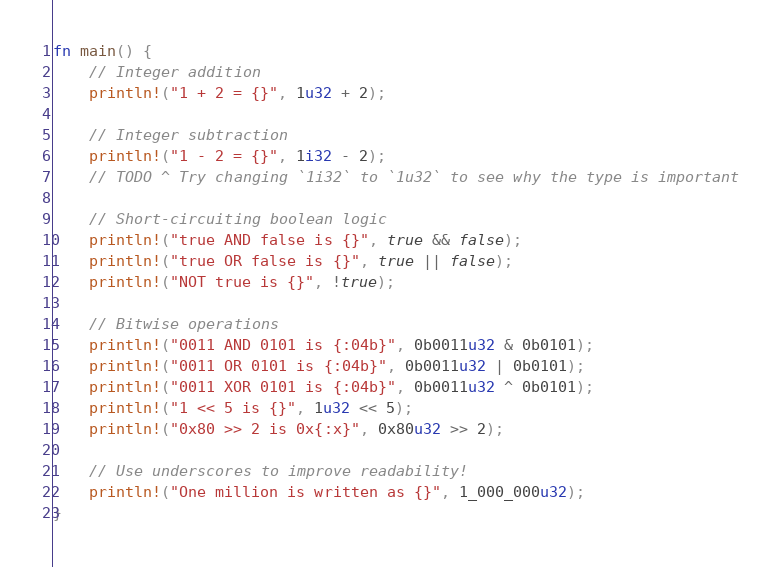Convert code to text. <code><loc_0><loc_0><loc_500><loc_500><_Rust_>fn main() {
    // Integer addition
    println!("1 + 2 = {}", 1u32 + 2);

    // Integer subtraction
    println!("1 - 2 = {}", 1i32 - 2);
    // TODO ^ Try changing `1i32` to `1u32` to see why the type is important

    // Short-circuiting boolean logic
    println!("true AND false is {}", true && false);
    println!("true OR false is {}", true || false);
    println!("NOT true is {}", !true);

    // Bitwise operations
    println!("0011 AND 0101 is {:04b}", 0b0011u32 & 0b0101);
    println!("0011 OR 0101 is {:04b}", 0b0011u32 | 0b0101);
    println!("0011 XOR 0101 is {:04b}", 0b0011u32 ^ 0b0101);
    println!("1 << 5 is {}", 1u32 << 5);
    println!("0x80 >> 2 is 0x{:x}", 0x80u32 >> 2);

    // Use underscores to improve readability!
    println!("One million is written as {}", 1_000_000u32);
}
</code> 